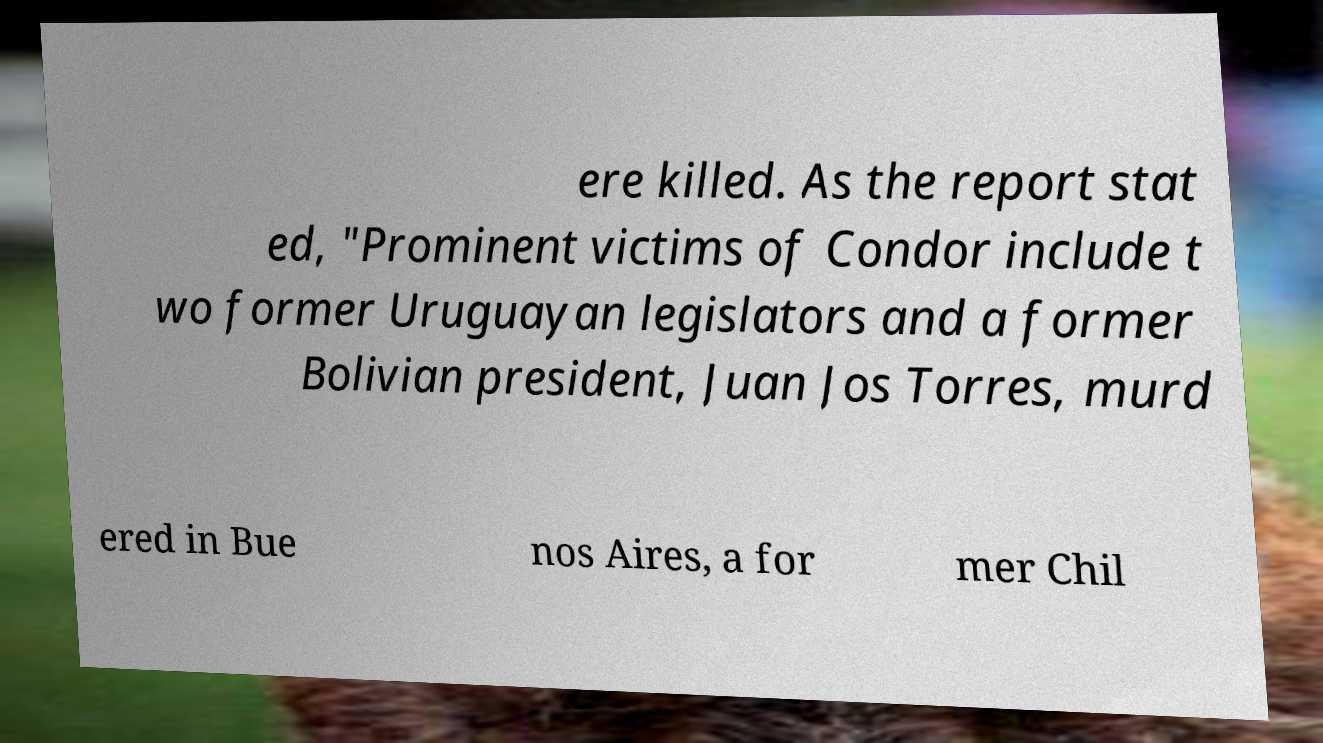Can you read and provide the text displayed in the image?This photo seems to have some interesting text. Can you extract and type it out for me? ere killed. As the report stat ed, "Prominent victims of Condor include t wo former Uruguayan legislators and a former Bolivian president, Juan Jos Torres, murd ered in Bue nos Aires, a for mer Chil 